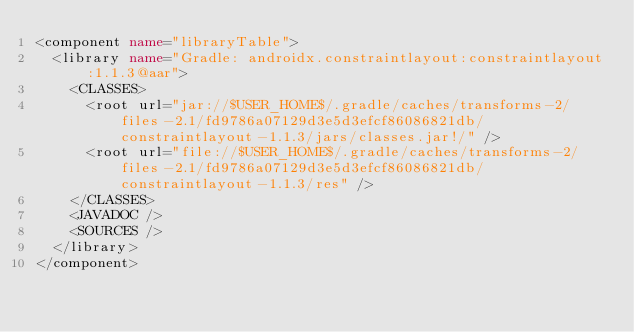<code> <loc_0><loc_0><loc_500><loc_500><_XML_><component name="libraryTable">
  <library name="Gradle: androidx.constraintlayout:constraintlayout:1.1.3@aar">
    <CLASSES>
      <root url="jar://$USER_HOME$/.gradle/caches/transforms-2/files-2.1/fd9786a07129d3e5d3efcf86086821db/constraintlayout-1.1.3/jars/classes.jar!/" />
      <root url="file://$USER_HOME$/.gradle/caches/transforms-2/files-2.1/fd9786a07129d3e5d3efcf86086821db/constraintlayout-1.1.3/res" />
    </CLASSES>
    <JAVADOC />
    <SOURCES />
  </library>
</component></code> 